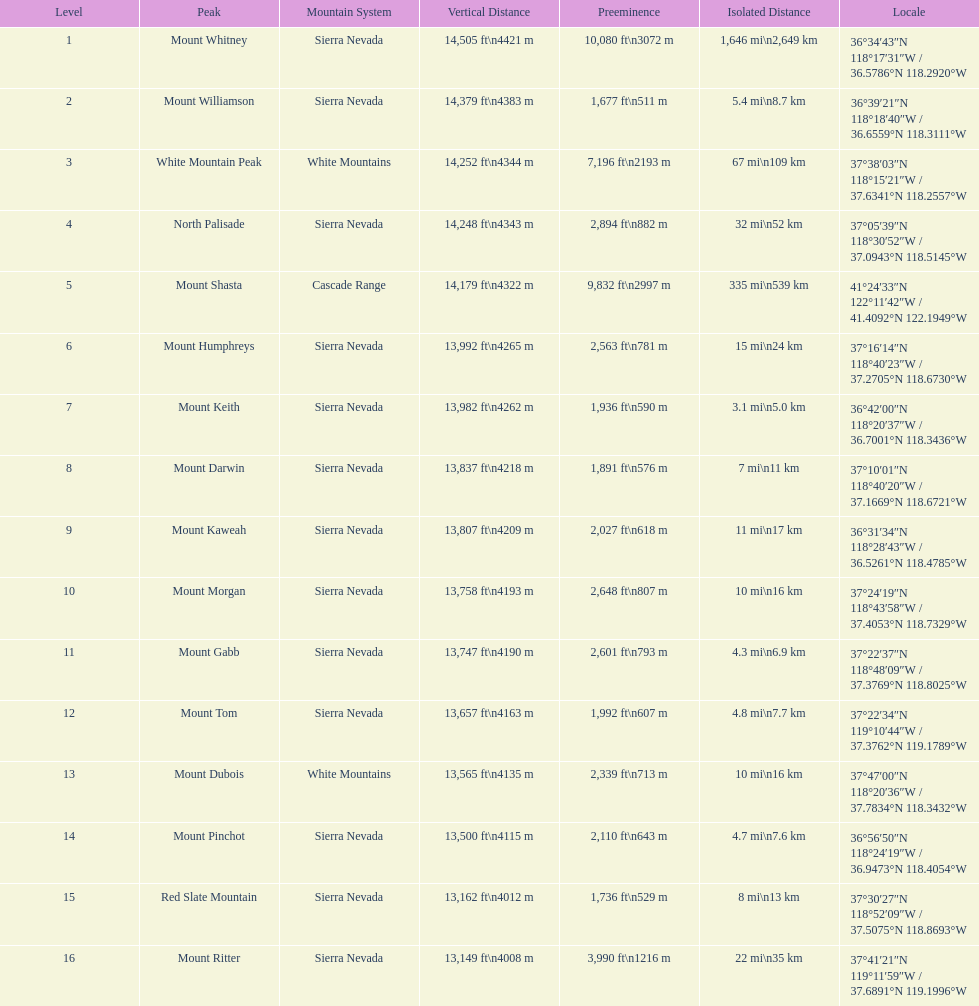How much higher is the mountain apex of mount williamson compared to mount keith's? 397 ft. 